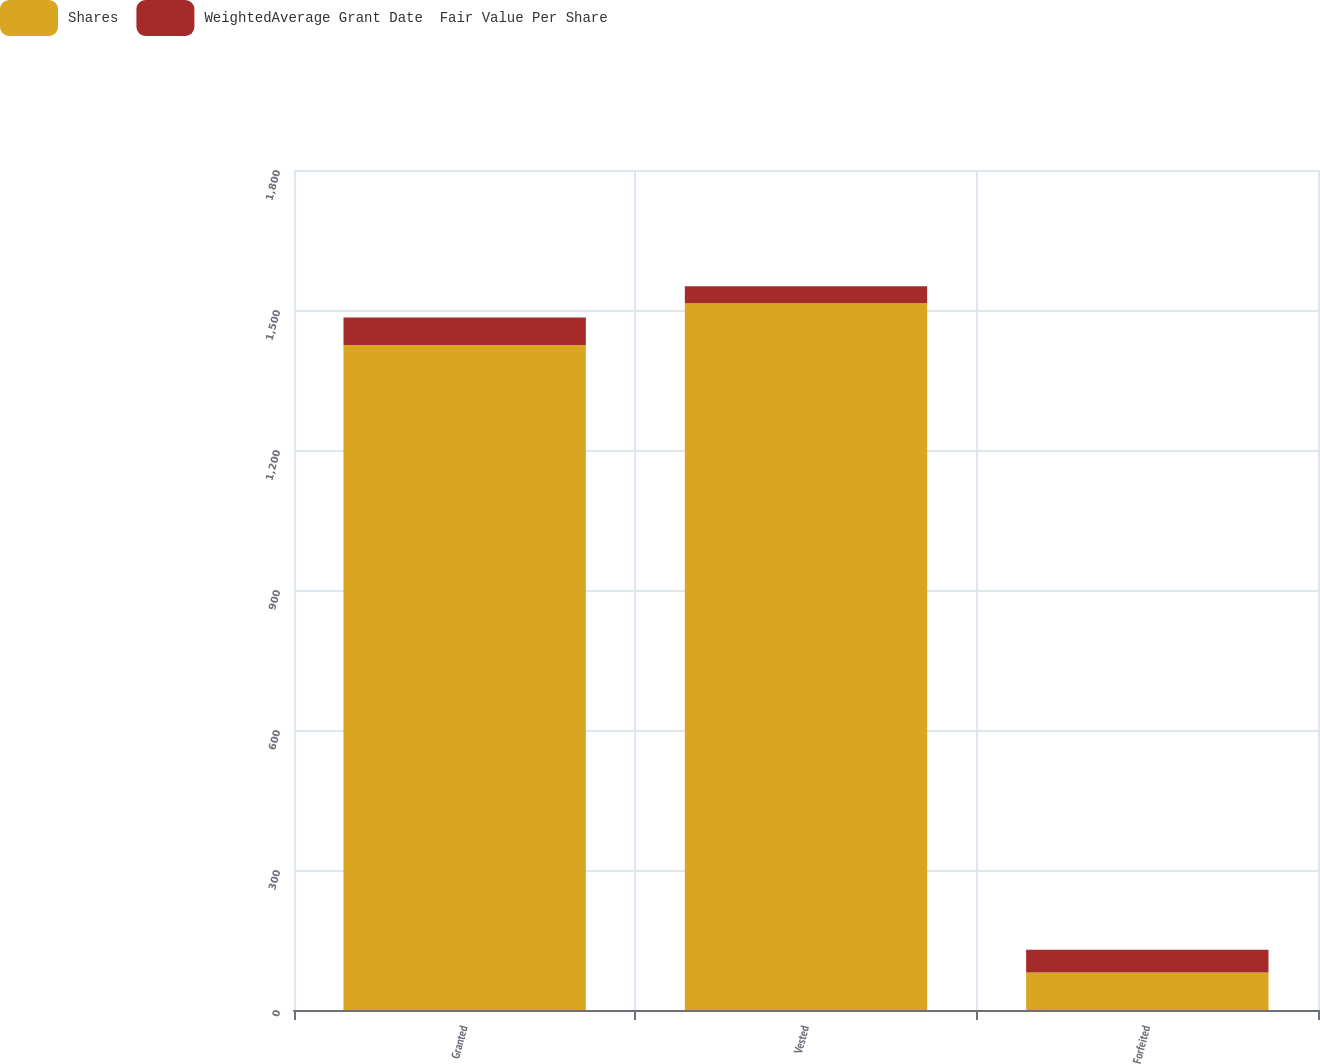Convert chart to OTSL. <chart><loc_0><loc_0><loc_500><loc_500><stacked_bar_chart><ecel><fcel>Granted<fcel>Vested<fcel>Forfeited<nl><fcel>Shares<fcel>1425<fcel>1514.7<fcel>80.4<nl><fcel>WeightedAverage Grant Date  Fair Value Per Share<fcel>59.02<fcel>36<fcel>48.96<nl></chart> 